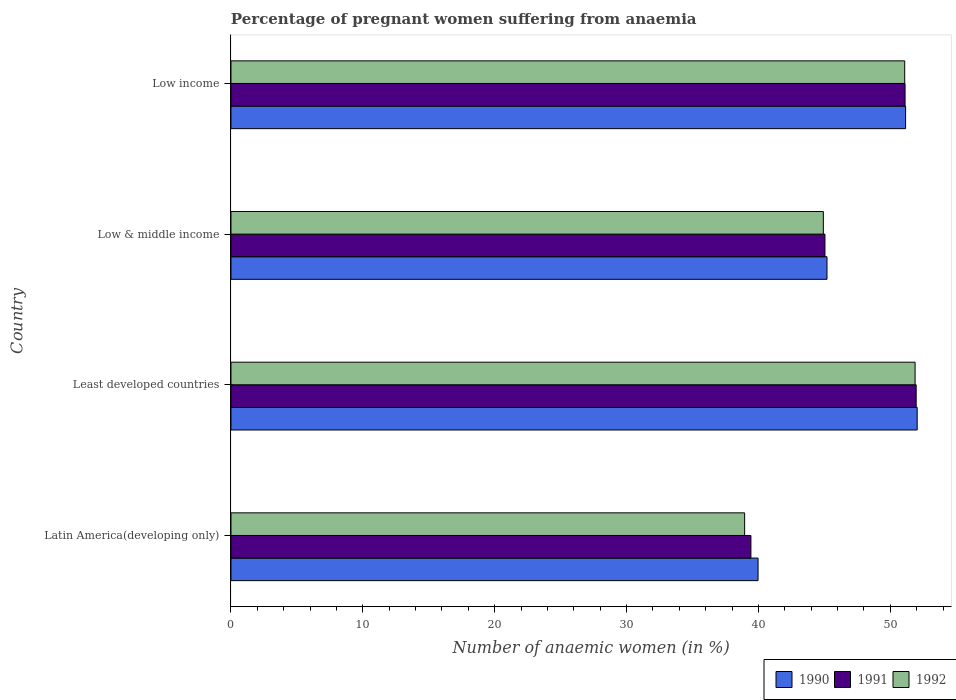How many groups of bars are there?
Make the answer very short. 4. What is the label of the 2nd group of bars from the top?
Your response must be concise. Low & middle income. In how many cases, is the number of bars for a given country not equal to the number of legend labels?
Keep it short and to the point. 0. What is the number of anaemic women in 1991 in Latin America(developing only)?
Keep it short and to the point. 39.43. Across all countries, what is the maximum number of anaemic women in 1990?
Offer a terse response. 52.03. Across all countries, what is the minimum number of anaemic women in 1990?
Provide a succinct answer. 39.97. In which country was the number of anaemic women in 1990 maximum?
Ensure brevity in your answer.  Least developed countries. In which country was the number of anaemic women in 1990 minimum?
Provide a short and direct response. Latin America(developing only). What is the total number of anaemic women in 1991 in the graph?
Offer a terse response. 187.54. What is the difference between the number of anaemic women in 1992 in Latin America(developing only) and that in Least developed countries?
Offer a terse response. -12.92. What is the difference between the number of anaemic women in 1990 in Latin America(developing only) and the number of anaemic women in 1992 in Low & middle income?
Keep it short and to the point. -4.95. What is the average number of anaemic women in 1990 per country?
Provide a succinct answer. 47.09. What is the difference between the number of anaemic women in 1991 and number of anaemic women in 1990 in Latin America(developing only)?
Ensure brevity in your answer.  -0.54. What is the ratio of the number of anaemic women in 1991 in Latin America(developing only) to that in Low & middle income?
Your response must be concise. 0.88. What is the difference between the highest and the second highest number of anaemic women in 1991?
Offer a very short reply. 0.84. What is the difference between the highest and the lowest number of anaemic women in 1992?
Offer a very short reply. 12.92. In how many countries, is the number of anaemic women in 1992 greater than the average number of anaemic women in 1992 taken over all countries?
Your answer should be compact. 2. Is the sum of the number of anaemic women in 1992 in Least developed countries and Low & middle income greater than the maximum number of anaemic women in 1991 across all countries?
Provide a succinct answer. Yes. What does the 2nd bar from the bottom in Least developed countries represents?
Offer a very short reply. 1991. What is the difference between two consecutive major ticks on the X-axis?
Provide a short and direct response. 10. Are the values on the major ticks of X-axis written in scientific E-notation?
Your answer should be compact. No. Does the graph contain any zero values?
Your answer should be very brief. No. Does the graph contain grids?
Provide a short and direct response. No. How many legend labels are there?
Provide a succinct answer. 3. How are the legend labels stacked?
Your answer should be very brief. Horizontal. What is the title of the graph?
Provide a succinct answer. Percentage of pregnant women suffering from anaemia. Does "1972" appear as one of the legend labels in the graph?
Keep it short and to the point. No. What is the label or title of the X-axis?
Provide a short and direct response. Number of anaemic women (in %). What is the Number of anaemic women (in %) in 1990 in Latin America(developing only)?
Provide a succinct answer. 39.97. What is the Number of anaemic women (in %) of 1991 in Latin America(developing only)?
Your response must be concise. 39.43. What is the Number of anaemic women (in %) of 1992 in Latin America(developing only)?
Your response must be concise. 38.95. What is the Number of anaemic women (in %) in 1990 in Least developed countries?
Your answer should be compact. 52.03. What is the Number of anaemic women (in %) of 1991 in Least developed countries?
Your answer should be compact. 51.96. What is the Number of anaemic women (in %) in 1992 in Least developed countries?
Your response must be concise. 51.88. What is the Number of anaemic women (in %) of 1990 in Low & middle income?
Give a very brief answer. 45.2. What is the Number of anaemic women (in %) in 1991 in Low & middle income?
Ensure brevity in your answer.  45.04. What is the Number of anaemic women (in %) in 1992 in Low & middle income?
Make the answer very short. 44.92. What is the Number of anaemic women (in %) in 1990 in Low income?
Provide a short and direct response. 51.16. What is the Number of anaemic women (in %) of 1991 in Low income?
Your response must be concise. 51.12. What is the Number of anaemic women (in %) in 1992 in Low income?
Make the answer very short. 51.09. Across all countries, what is the maximum Number of anaemic women (in %) in 1990?
Your answer should be compact. 52.03. Across all countries, what is the maximum Number of anaemic women (in %) of 1991?
Your answer should be very brief. 51.96. Across all countries, what is the maximum Number of anaemic women (in %) of 1992?
Offer a terse response. 51.88. Across all countries, what is the minimum Number of anaemic women (in %) of 1990?
Your answer should be very brief. 39.97. Across all countries, what is the minimum Number of anaemic women (in %) of 1991?
Make the answer very short. 39.43. Across all countries, what is the minimum Number of anaemic women (in %) of 1992?
Offer a very short reply. 38.95. What is the total Number of anaemic women (in %) in 1990 in the graph?
Provide a short and direct response. 188.36. What is the total Number of anaemic women (in %) of 1991 in the graph?
Provide a short and direct response. 187.54. What is the total Number of anaemic women (in %) of 1992 in the graph?
Offer a very short reply. 186.83. What is the difference between the Number of anaemic women (in %) of 1990 in Latin America(developing only) and that in Least developed countries?
Your answer should be compact. -12.07. What is the difference between the Number of anaemic women (in %) in 1991 in Latin America(developing only) and that in Least developed countries?
Keep it short and to the point. -12.53. What is the difference between the Number of anaemic women (in %) in 1992 in Latin America(developing only) and that in Least developed countries?
Keep it short and to the point. -12.92. What is the difference between the Number of anaemic women (in %) of 1990 in Latin America(developing only) and that in Low & middle income?
Offer a terse response. -5.23. What is the difference between the Number of anaemic women (in %) of 1991 in Latin America(developing only) and that in Low & middle income?
Provide a short and direct response. -5.61. What is the difference between the Number of anaemic women (in %) in 1992 in Latin America(developing only) and that in Low & middle income?
Keep it short and to the point. -5.97. What is the difference between the Number of anaemic women (in %) in 1990 in Latin America(developing only) and that in Low income?
Give a very brief answer. -11.19. What is the difference between the Number of anaemic women (in %) in 1991 in Latin America(developing only) and that in Low income?
Provide a succinct answer. -11.69. What is the difference between the Number of anaemic women (in %) of 1992 in Latin America(developing only) and that in Low income?
Offer a very short reply. -12.14. What is the difference between the Number of anaemic women (in %) of 1990 in Least developed countries and that in Low & middle income?
Offer a very short reply. 6.84. What is the difference between the Number of anaemic women (in %) in 1991 in Least developed countries and that in Low & middle income?
Give a very brief answer. 6.92. What is the difference between the Number of anaemic women (in %) in 1992 in Least developed countries and that in Low & middle income?
Your response must be concise. 6.96. What is the difference between the Number of anaemic women (in %) of 1990 in Least developed countries and that in Low income?
Provide a succinct answer. 0.88. What is the difference between the Number of anaemic women (in %) of 1991 in Least developed countries and that in Low income?
Ensure brevity in your answer.  0.84. What is the difference between the Number of anaemic women (in %) in 1992 in Least developed countries and that in Low income?
Give a very brief answer. 0.79. What is the difference between the Number of anaemic women (in %) in 1990 in Low & middle income and that in Low income?
Offer a very short reply. -5.96. What is the difference between the Number of anaemic women (in %) of 1991 in Low & middle income and that in Low income?
Make the answer very short. -6.08. What is the difference between the Number of anaemic women (in %) of 1992 in Low & middle income and that in Low income?
Your answer should be compact. -6.17. What is the difference between the Number of anaemic women (in %) of 1990 in Latin America(developing only) and the Number of anaemic women (in %) of 1991 in Least developed countries?
Ensure brevity in your answer.  -11.99. What is the difference between the Number of anaemic women (in %) in 1990 in Latin America(developing only) and the Number of anaemic women (in %) in 1992 in Least developed countries?
Provide a short and direct response. -11.91. What is the difference between the Number of anaemic women (in %) of 1991 in Latin America(developing only) and the Number of anaemic women (in %) of 1992 in Least developed countries?
Your answer should be compact. -12.45. What is the difference between the Number of anaemic women (in %) of 1990 in Latin America(developing only) and the Number of anaemic women (in %) of 1991 in Low & middle income?
Your response must be concise. -5.07. What is the difference between the Number of anaemic women (in %) of 1990 in Latin America(developing only) and the Number of anaemic women (in %) of 1992 in Low & middle income?
Provide a short and direct response. -4.95. What is the difference between the Number of anaemic women (in %) of 1991 in Latin America(developing only) and the Number of anaemic women (in %) of 1992 in Low & middle income?
Keep it short and to the point. -5.49. What is the difference between the Number of anaemic women (in %) in 1990 in Latin America(developing only) and the Number of anaemic women (in %) in 1991 in Low income?
Make the answer very short. -11.15. What is the difference between the Number of anaemic women (in %) of 1990 in Latin America(developing only) and the Number of anaemic women (in %) of 1992 in Low income?
Offer a very short reply. -11.12. What is the difference between the Number of anaemic women (in %) of 1991 in Latin America(developing only) and the Number of anaemic women (in %) of 1992 in Low income?
Your answer should be compact. -11.66. What is the difference between the Number of anaemic women (in %) in 1990 in Least developed countries and the Number of anaemic women (in %) in 1991 in Low & middle income?
Give a very brief answer. 6.99. What is the difference between the Number of anaemic women (in %) of 1990 in Least developed countries and the Number of anaemic women (in %) of 1992 in Low & middle income?
Provide a short and direct response. 7.12. What is the difference between the Number of anaemic women (in %) of 1991 in Least developed countries and the Number of anaemic women (in %) of 1992 in Low & middle income?
Your answer should be compact. 7.04. What is the difference between the Number of anaemic women (in %) in 1990 in Least developed countries and the Number of anaemic women (in %) in 1991 in Low income?
Your answer should be compact. 0.92. What is the difference between the Number of anaemic women (in %) of 1990 in Least developed countries and the Number of anaemic women (in %) of 1992 in Low income?
Provide a short and direct response. 0.95. What is the difference between the Number of anaemic women (in %) of 1991 in Least developed countries and the Number of anaemic women (in %) of 1992 in Low income?
Provide a succinct answer. 0.87. What is the difference between the Number of anaemic women (in %) in 1990 in Low & middle income and the Number of anaemic women (in %) in 1991 in Low income?
Provide a succinct answer. -5.92. What is the difference between the Number of anaemic women (in %) in 1990 in Low & middle income and the Number of anaemic women (in %) in 1992 in Low income?
Ensure brevity in your answer.  -5.89. What is the difference between the Number of anaemic women (in %) in 1991 in Low & middle income and the Number of anaemic women (in %) in 1992 in Low income?
Provide a succinct answer. -6.05. What is the average Number of anaemic women (in %) of 1990 per country?
Your response must be concise. 47.09. What is the average Number of anaemic women (in %) in 1991 per country?
Offer a very short reply. 46.89. What is the average Number of anaemic women (in %) of 1992 per country?
Your answer should be compact. 46.71. What is the difference between the Number of anaemic women (in %) in 1990 and Number of anaemic women (in %) in 1991 in Latin America(developing only)?
Offer a very short reply. 0.54. What is the difference between the Number of anaemic women (in %) of 1990 and Number of anaemic women (in %) of 1992 in Latin America(developing only)?
Make the answer very short. 1.02. What is the difference between the Number of anaemic women (in %) in 1991 and Number of anaemic women (in %) in 1992 in Latin America(developing only)?
Your response must be concise. 0.48. What is the difference between the Number of anaemic women (in %) of 1990 and Number of anaemic women (in %) of 1991 in Least developed countries?
Your answer should be compact. 0.08. What is the difference between the Number of anaemic women (in %) in 1990 and Number of anaemic women (in %) in 1992 in Least developed countries?
Provide a short and direct response. 0.16. What is the difference between the Number of anaemic women (in %) in 1991 and Number of anaemic women (in %) in 1992 in Least developed countries?
Offer a terse response. 0.08. What is the difference between the Number of anaemic women (in %) of 1990 and Number of anaemic women (in %) of 1991 in Low & middle income?
Give a very brief answer. 0.16. What is the difference between the Number of anaemic women (in %) in 1990 and Number of anaemic women (in %) in 1992 in Low & middle income?
Provide a succinct answer. 0.28. What is the difference between the Number of anaemic women (in %) of 1991 and Number of anaemic women (in %) of 1992 in Low & middle income?
Provide a succinct answer. 0.12. What is the difference between the Number of anaemic women (in %) in 1990 and Number of anaemic women (in %) in 1991 in Low income?
Provide a short and direct response. 0.04. What is the difference between the Number of anaemic women (in %) of 1990 and Number of anaemic women (in %) of 1992 in Low income?
Your answer should be very brief. 0.07. What is the difference between the Number of anaemic women (in %) in 1991 and Number of anaemic women (in %) in 1992 in Low income?
Keep it short and to the point. 0.03. What is the ratio of the Number of anaemic women (in %) in 1990 in Latin America(developing only) to that in Least developed countries?
Your answer should be compact. 0.77. What is the ratio of the Number of anaemic women (in %) in 1991 in Latin America(developing only) to that in Least developed countries?
Offer a terse response. 0.76. What is the ratio of the Number of anaemic women (in %) in 1992 in Latin America(developing only) to that in Least developed countries?
Your answer should be compact. 0.75. What is the ratio of the Number of anaemic women (in %) in 1990 in Latin America(developing only) to that in Low & middle income?
Your answer should be compact. 0.88. What is the ratio of the Number of anaemic women (in %) of 1991 in Latin America(developing only) to that in Low & middle income?
Make the answer very short. 0.88. What is the ratio of the Number of anaemic women (in %) in 1992 in Latin America(developing only) to that in Low & middle income?
Make the answer very short. 0.87. What is the ratio of the Number of anaemic women (in %) in 1990 in Latin America(developing only) to that in Low income?
Keep it short and to the point. 0.78. What is the ratio of the Number of anaemic women (in %) of 1991 in Latin America(developing only) to that in Low income?
Provide a succinct answer. 0.77. What is the ratio of the Number of anaemic women (in %) in 1992 in Latin America(developing only) to that in Low income?
Your response must be concise. 0.76. What is the ratio of the Number of anaemic women (in %) of 1990 in Least developed countries to that in Low & middle income?
Provide a succinct answer. 1.15. What is the ratio of the Number of anaemic women (in %) of 1991 in Least developed countries to that in Low & middle income?
Offer a terse response. 1.15. What is the ratio of the Number of anaemic women (in %) of 1992 in Least developed countries to that in Low & middle income?
Make the answer very short. 1.15. What is the ratio of the Number of anaemic women (in %) of 1990 in Least developed countries to that in Low income?
Your answer should be very brief. 1.02. What is the ratio of the Number of anaemic women (in %) of 1991 in Least developed countries to that in Low income?
Give a very brief answer. 1.02. What is the ratio of the Number of anaemic women (in %) of 1992 in Least developed countries to that in Low income?
Offer a terse response. 1.02. What is the ratio of the Number of anaemic women (in %) in 1990 in Low & middle income to that in Low income?
Keep it short and to the point. 0.88. What is the ratio of the Number of anaemic women (in %) of 1991 in Low & middle income to that in Low income?
Provide a short and direct response. 0.88. What is the ratio of the Number of anaemic women (in %) of 1992 in Low & middle income to that in Low income?
Your answer should be compact. 0.88. What is the difference between the highest and the second highest Number of anaemic women (in %) in 1990?
Your response must be concise. 0.88. What is the difference between the highest and the second highest Number of anaemic women (in %) in 1991?
Your response must be concise. 0.84. What is the difference between the highest and the second highest Number of anaemic women (in %) of 1992?
Give a very brief answer. 0.79. What is the difference between the highest and the lowest Number of anaemic women (in %) in 1990?
Ensure brevity in your answer.  12.07. What is the difference between the highest and the lowest Number of anaemic women (in %) in 1991?
Keep it short and to the point. 12.53. What is the difference between the highest and the lowest Number of anaemic women (in %) in 1992?
Your answer should be very brief. 12.92. 